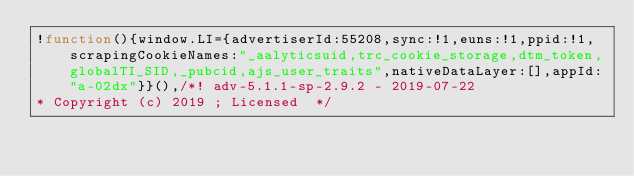<code> <loc_0><loc_0><loc_500><loc_500><_JavaScript_>!function(){window.LI={advertiserId:55208,sync:!1,euns:!1,ppid:!1,scrapingCookieNames:"_aalyticsuid,trc_cookie_storage,dtm_token,globalTI_SID,_pubcid,ajs_user_traits",nativeDataLayer:[],appId:"a-02dx"}}(),/*! adv-5.1.1-sp-2.9.2 - 2019-07-22
* Copyright (c) 2019 ; Licensed  */</code> 